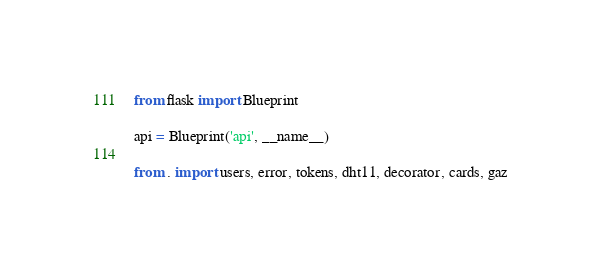<code> <loc_0><loc_0><loc_500><loc_500><_Python_>from flask import Blueprint

api = Blueprint('api', __name__)

from . import users, error, tokens, dht11, decorator, cards, gaz

</code> 